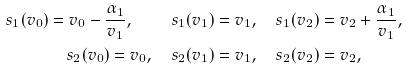<formula> <loc_0><loc_0><loc_500><loc_500>s _ { 1 } ( v _ { 0 } ) = v _ { 0 } - \frac { \alpha _ { 1 } } { v _ { 1 } } , \quad s _ { 1 } ( v _ { 1 } ) & = v _ { 1 } , \quad s _ { 1 } ( v _ { 2 } ) = v _ { 2 } + \frac { \alpha _ { 1 } } { v _ { 1 } } , \\ s _ { 2 } ( v _ { 0 } ) = v _ { 0 } , \quad s _ { 2 } ( v _ { 1 } ) & = v _ { 1 } , \quad s _ { 2 } ( v _ { 2 } ) = v _ { 2 } ,</formula> 